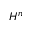<formula> <loc_0><loc_0><loc_500><loc_500>H ^ { n }</formula> 